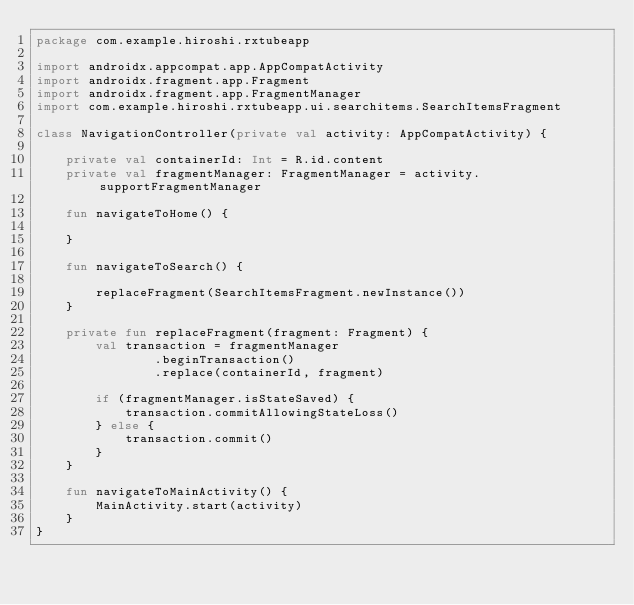Convert code to text. <code><loc_0><loc_0><loc_500><loc_500><_Kotlin_>package com.example.hiroshi.rxtubeapp

import androidx.appcompat.app.AppCompatActivity
import androidx.fragment.app.Fragment
import androidx.fragment.app.FragmentManager
import com.example.hiroshi.rxtubeapp.ui.searchitems.SearchItemsFragment

class NavigationController(private val activity: AppCompatActivity) {

    private val containerId: Int = R.id.content
    private val fragmentManager: FragmentManager = activity.supportFragmentManager

    fun navigateToHome() {

    }

    fun navigateToSearch() {

        replaceFragment(SearchItemsFragment.newInstance())
    }

    private fun replaceFragment(fragment: Fragment) {
        val transaction = fragmentManager
                .beginTransaction()
                .replace(containerId, fragment)

        if (fragmentManager.isStateSaved) {
            transaction.commitAllowingStateLoss()
        } else {
            transaction.commit()
        }
    }

    fun navigateToMainActivity() {
        MainActivity.start(activity)
    }
}</code> 